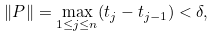<formula> <loc_0><loc_0><loc_500><loc_500>\| P \| = \underset { 1 \leq j \leq n } { \max } ( t _ { j } - t _ { j - 1 } ) < \delta ,</formula> 